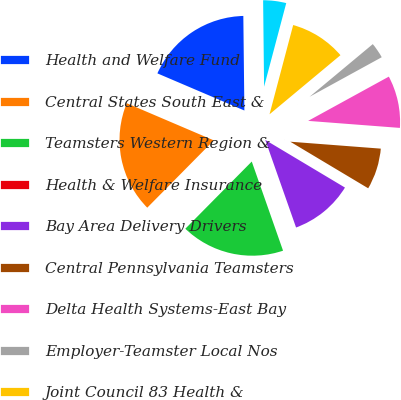Convert chart to OTSL. <chart><loc_0><loc_0><loc_500><loc_500><pie_chart><fcel>Health and Welfare Fund<fcel>Central States South East &<fcel>Teamsters Western Region &<fcel>Health & Welfare Insurance<fcel>Bay Area Delivery Drivers<fcel>Central Pennsylvania Teamsters<fcel>Delta Health Systems-East Bay<fcel>Employer-Teamster Local Nos<fcel>Joint Council 83 Health &<fcel>Local 191 Teamsters Health<nl><fcel>18.4%<fcel>19.01%<fcel>17.78%<fcel>0.01%<fcel>11.04%<fcel>7.36%<fcel>9.2%<fcel>3.07%<fcel>9.82%<fcel>4.3%<nl></chart> 